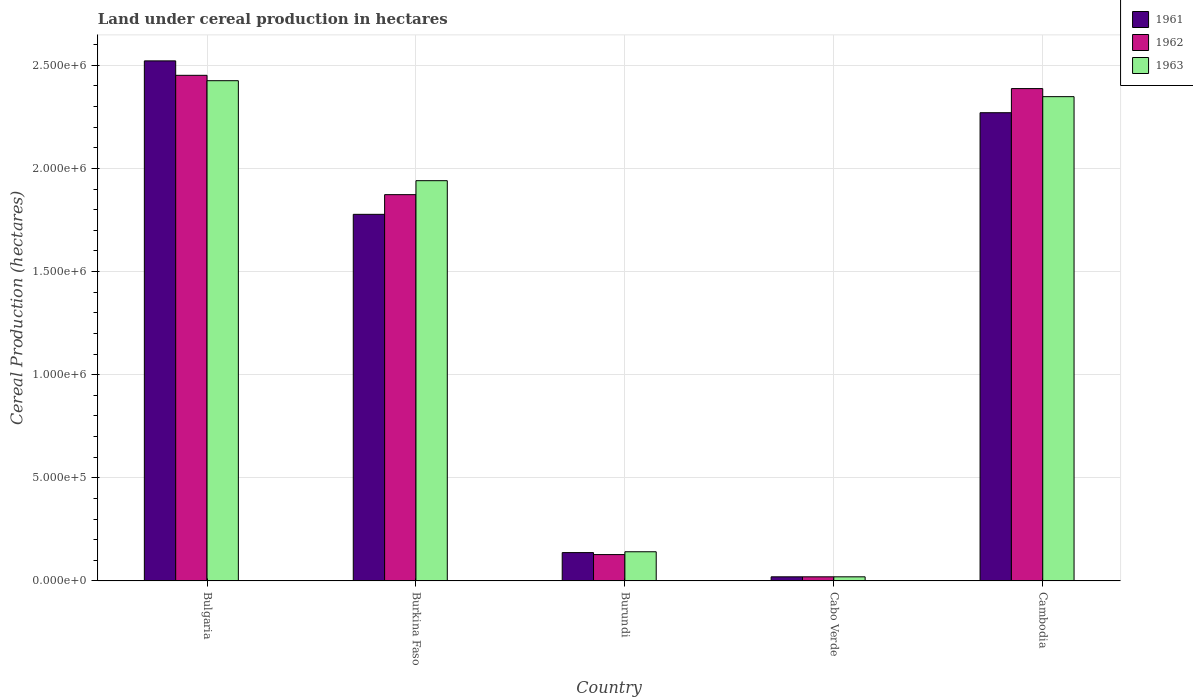How many different coloured bars are there?
Ensure brevity in your answer.  3. How many groups of bars are there?
Provide a short and direct response. 5. Are the number of bars per tick equal to the number of legend labels?
Make the answer very short. Yes. How many bars are there on the 4th tick from the left?
Ensure brevity in your answer.  3. What is the label of the 3rd group of bars from the left?
Provide a short and direct response. Burundi. In how many cases, is the number of bars for a given country not equal to the number of legend labels?
Ensure brevity in your answer.  0. Across all countries, what is the maximum land under cereal production in 1963?
Keep it short and to the point. 2.43e+06. Across all countries, what is the minimum land under cereal production in 1962?
Provide a succinct answer. 2.00e+04. In which country was the land under cereal production in 1961 maximum?
Ensure brevity in your answer.  Bulgaria. In which country was the land under cereal production in 1961 minimum?
Ensure brevity in your answer.  Cabo Verde. What is the total land under cereal production in 1963 in the graph?
Your answer should be compact. 6.88e+06. What is the difference between the land under cereal production in 1963 in Burkina Faso and that in Cambodia?
Make the answer very short. -4.07e+05. What is the difference between the land under cereal production in 1961 in Cabo Verde and the land under cereal production in 1963 in Burkina Faso?
Make the answer very short. -1.92e+06. What is the average land under cereal production in 1962 per country?
Your response must be concise. 1.37e+06. What is the difference between the land under cereal production of/in 1961 and land under cereal production of/in 1962 in Burundi?
Your answer should be compact. 9597. What is the ratio of the land under cereal production in 1963 in Bulgaria to that in Cabo Verde?
Offer a very short reply. 121.26. Is the land under cereal production in 1963 in Burkina Faso less than that in Cambodia?
Offer a terse response. Yes. What is the difference between the highest and the second highest land under cereal production in 1963?
Your answer should be very brief. -7.73e+04. What is the difference between the highest and the lowest land under cereal production in 1961?
Offer a terse response. 2.50e+06. What does the 2nd bar from the left in Bulgaria represents?
Your response must be concise. 1962. What does the 2nd bar from the right in Bulgaria represents?
Your answer should be compact. 1962. Are all the bars in the graph horizontal?
Ensure brevity in your answer.  No. Are the values on the major ticks of Y-axis written in scientific E-notation?
Provide a short and direct response. Yes. What is the title of the graph?
Your answer should be very brief. Land under cereal production in hectares. Does "2005" appear as one of the legend labels in the graph?
Give a very brief answer. No. What is the label or title of the X-axis?
Offer a terse response. Country. What is the label or title of the Y-axis?
Keep it short and to the point. Cereal Production (hectares). What is the Cereal Production (hectares) in 1961 in Bulgaria?
Make the answer very short. 2.52e+06. What is the Cereal Production (hectares) of 1962 in Bulgaria?
Offer a very short reply. 2.45e+06. What is the Cereal Production (hectares) of 1963 in Bulgaria?
Your answer should be very brief. 2.43e+06. What is the Cereal Production (hectares) in 1961 in Burkina Faso?
Offer a very short reply. 1.78e+06. What is the Cereal Production (hectares) of 1962 in Burkina Faso?
Offer a very short reply. 1.87e+06. What is the Cereal Production (hectares) in 1963 in Burkina Faso?
Give a very brief answer. 1.94e+06. What is the Cereal Production (hectares) in 1961 in Burundi?
Provide a short and direct response. 1.37e+05. What is the Cereal Production (hectares) of 1962 in Burundi?
Your answer should be very brief. 1.28e+05. What is the Cereal Production (hectares) of 1963 in Burundi?
Your answer should be very brief. 1.41e+05. What is the Cereal Production (hectares) of 1961 in Cambodia?
Ensure brevity in your answer.  2.27e+06. What is the Cereal Production (hectares) in 1962 in Cambodia?
Offer a very short reply. 2.39e+06. What is the Cereal Production (hectares) in 1963 in Cambodia?
Offer a terse response. 2.35e+06. Across all countries, what is the maximum Cereal Production (hectares) in 1961?
Make the answer very short. 2.52e+06. Across all countries, what is the maximum Cereal Production (hectares) in 1962?
Give a very brief answer. 2.45e+06. Across all countries, what is the maximum Cereal Production (hectares) in 1963?
Ensure brevity in your answer.  2.43e+06. Across all countries, what is the minimum Cereal Production (hectares) in 1962?
Your response must be concise. 2.00e+04. Across all countries, what is the minimum Cereal Production (hectares) of 1963?
Provide a short and direct response. 2.00e+04. What is the total Cereal Production (hectares) in 1961 in the graph?
Keep it short and to the point. 6.73e+06. What is the total Cereal Production (hectares) in 1962 in the graph?
Offer a very short reply. 6.86e+06. What is the total Cereal Production (hectares) in 1963 in the graph?
Your response must be concise. 6.88e+06. What is the difference between the Cereal Production (hectares) of 1961 in Bulgaria and that in Burkina Faso?
Your answer should be compact. 7.44e+05. What is the difference between the Cereal Production (hectares) in 1962 in Bulgaria and that in Burkina Faso?
Provide a short and direct response. 5.79e+05. What is the difference between the Cereal Production (hectares) of 1963 in Bulgaria and that in Burkina Faso?
Offer a very short reply. 4.85e+05. What is the difference between the Cereal Production (hectares) of 1961 in Bulgaria and that in Burundi?
Provide a succinct answer. 2.38e+06. What is the difference between the Cereal Production (hectares) in 1962 in Bulgaria and that in Burundi?
Provide a succinct answer. 2.32e+06. What is the difference between the Cereal Production (hectares) in 1963 in Bulgaria and that in Burundi?
Your answer should be very brief. 2.28e+06. What is the difference between the Cereal Production (hectares) in 1961 in Bulgaria and that in Cabo Verde?
Your answer should be compact. 2.50e+06. What is the difference between the Cereal Production (hectares) in 1962 in Bulgaria and that in Cabo Verde?
Give a very brief answer. 2.43e+06. What is the difference between the Cereal Production (hectares) in 1963 in Bulgaria and that in Cabo Verde?
Provide a succinct answer. 2.41e+06. What is the difference between the Cereal Production (hectares) in 1961 in Bulgaria and that in Cambodia?
Give a very brief answer. 2.51e+05. What is the difference between the Cereal Production (hectares) in 1962 in Bulgaria and that in Cambodia?
Ensure brevity in your answer.  6.43e+04. What is the difference between the Cereal Production (hectares) in 1963 in Bulgaria and that in Cambodia?
Your response must be concise. 7.73e+04. What is the difference between the Cereal Production (hectares) in 1961 in Burkina Faso and that in Burundi?
Ensure brevity in your answer.  1.64e+06. What is the difference between the Cereal Production (hectares) in 1962 in Burkina Faso and that in Burundi?
Your response must be concise. 1.75e+06. What is the difference between the Cereal Production (hectares) of 1963 in Burkina Faso and that in Burundi?
Make the answer very short. 1.80e+06. What is the difference between the Cereal Production (hectares) of 1961 in Burkina Faso and that in Cabo Verde?
Your answer should be compact. 1.76e+06. What is the difference between the Cereal Production (hectares) of 1962 in Burkina Faso and that in Cabo Verde?
Make the answer very short. 1.85e+06. What is the difference between the Cereal Production (hectares) of 1963 in Burkina Faso and that in Cabo Verde?
Give a very brief answer. 1.92e+06. What is the difference between the Cereal Production (hectares) of 1961 in Burkina Faso and that in Cambodia?
Provide a short and direct response. -4.93e+05. What is the difference between the Cereal Production (hectares) of 1962 in Burkina Faso and that in Cambodia?
Make the answer very short. -5.14e+05. What is the difference between the Cereal Production (hectares) in 1963 in Burkina Faso and that in Cambodia?
Provide a succinct answer. -4.07e+05. What is the difference between the Cereal Production (hectares) of 1961 in Burundi and that in Cabo Verde?
Keep it short and to the point. 1.17e+05. What is the difference between the Cereal Production (hectares) in 1962 in Burundi and that in Cabo Verde?
Give a very brief answer. 1.08e+05. What is the difference between the Cereal Production (hectares) in 1963 in Burundi and that in Cabo Verde?
Your response must be concise. 1.21e+05. What is the difference between the Cereal Production (hectares) of 1961 in Burundi and that in Cambodia?
Your response must be concise. -2.13e+06. What is the difference between the Cereal Production (hectares) in 1962 in Burundi and that in Cambodia?
Offer a very short reply. -2.26e+06. What is the difference between the Cereal Production (hectares) of 1963 in Burundi and that in Cambodia?
Ensure brevity in your answer.  -2.21e+06. What is the difference between the Cereal Production (hectares) in 1961 in Cabo Verde and that in Cambodia?
Give a very brief answer. -2.25e+06. What is the difference between the Cereal Production (hectares) of 1962 in Cabo Verde and that in Cambodia?
Offer a terse response. -2.37e+06. What is the difference between the Cereal Production (hectares) of 1963 in Cabo Verde and that in Cambodia?
Provide a succinct answer. -2.33e+06. What is the difference between the Cereal Production (hectares) of 1961 in Bulgaria and the Cereal Production (hectares) of 1962 in Burkina Faso?
Your answer should be compact. 6.49e+05. What is the difference between the Cereal Production (hectares) in 1961 in Bulgaria and the Cereal Production (hectares) in 1963 in Burkina Faso?
Ensure brevity in your answer.  5.81e+05. What is the difference between the Cereal Production (hectares) of 1962 in Bulgaria and the Cereal Production (hectares) of 1963 in Burkina Faso?
Offer a terse response. 5.11e+05. What is the difference between the Cereal Production (hectares) of 1961 in Bulgaria and the Cereal Production (hectares) of 1962 in Burundi?
Provide a succinct answer. 2.39e+06. What is the difference between the Cereal Production (hectares) of 1961 in Bulgaria and the Cereal Production (hectares) of 1963 in Burundi?
Provide a succinct answer. 2.38e+06. What is the difference between the Cereal Production (hectares) in 1962 in Bulgaria and the Cereal Production (hectares) in 1963 in Burundi?
Provide a succinct answer. 2.31e+06. What is the difference between the Cereal Production (hectares) in 1961 in Bulgaria and the Cereal Production (hectares) in 1962 in Cabo Verde?
Offer a very short reply. 2.50e+06. What is the difference between the Cereal Production (hectares) in 1961 in Bulgaria and the Cereal Production (hectares) in 1963 in Cabo Verde?
Give a very brief answer. 2.50e+06. What is the difference between the Cereal Production (hectares) in 1962 in Bulgaria and the Cereal Production (hectares) in 1963 in Cabo Verde?
Give a very brief answer. 2.43e+06. What is the difference between the Cereal Production (hectares) in 1961 in Bulgaria and the Cereal Production (hectares) in 1962 in Cambodia?
Offer a very short reply. 1.34e+05. What is the difference between the Cereal Production (hectares) in 1961 in Bulgaria and the Cereal Production (hectares) in 1963 in Cambodia?
Your answer should be compact. 1.73e+05. What is the difference between the Cereal Production (hectares) of 1962 in Bulgaria and the Cereal Production (hectares) of 1963 in Cambodia?
Your answer should be very brief. 1.03e+05. What is the difference between the Cereal Production (hectares) in 1961 in Burkina Faso and the Cereal Production (hectares) in 1962 in Burundi?
Your response must be concise. 1.65e+06. What is the difference between the Cereal Production (hectares) of 1961 in Burkina Faso and the Cereal Production (hectares) of 1963 in Burundi?
Keep it short and to the point. 1.64e+06. What is the difference between the Cereal Production (hectares) of 1962 in Burkina Faso and the Cereal Production (hectares) of 1963 in Burundi?
Your response must be concise. 1.73e+06. What is the difference between the Cereal Production (hectares) in 1961 in Burkina Faso and the Cereal Production (hectares) in 1962 in Cabo Verde?
Make the answer very short. 1.76e+06. What is the difference between the Cereal Production (hectares) of 1961 in Burkina Faso and the Cereal Production (hectares) of 1963 in Cabo Verde?
Keep it short and to the point. 1.76e+06. What is the difference between the Cereal Production (hectares) in 1962 in Burkina Faso and the Cereal Production (hectares) in 1963 in Cabo Verde?
Ensure brevity in your answer.  1.85e+06. What is the difference between the Cereal Production (hectares) in 1961 in Burkina Faso and the Cereal Production (hectares) in 1962 in Cambodia?
Provide a short and direct response. -6.10e+05. What is the difference between the Cereal Production (hectares) of 1961 in Burkina Faso and the Cereal Production (hectares) of 1963 in Cambodia?
Your response must be concise. -5.71e+05. What is the difference between the Cereal Production (hectares) of 1962 in Burkina Faso and the Cereal Production (hectares) of 1963 in Cambodia?
Your answer should be compact. -4.75e+05. What is the difference between the Cereal Production (hectares) in 1961 in Burundi and the Cereal Production (hectares) in 1962 in Cabo Verde?
Your answer should be compact. 1.17e+05. What is the difference between the Cereal Production (hectares) in 1961 in Burundi and the Cereal Production (hectares) in 1963 in Cabo Verde?
Offer a very short reply. 1.17e+05. What is the difference between the Cereal Production (hectares) of 1962 in Burundi and the Cereal Production (hectares) of 1963 in Cabo Verde?
Keep it short and to the point. 1.08e+05. What is the difference between the Cereal Production (hectares) in 1961 in Burundi and the Cereal Production (hectares) in 1962 in Cambodia?
Your answer should be compact. -2.25e+06. What is the difference between the Cereal Production (hectares) in 1961 in Burundi and the Cereal Production (hectares) in 1963 in Cambodia?
Offer a terse response. -2.21e+06. What is the difference between the Cereal Production (hectares) in 1962 in Burundi and the Cereal Production (hectares) in 1963 in Cambodia?
Give a very brief answer. -2.22e+06. What is the difference between the Cereal Production (hectares) of 1961 in Cabo Verde and the Cereal Production (hectares) of 1962 in Cambodia?
Offer a very short reply. -2.37e+06. What is the difference between the Cereal Production (hectares) of 1961 in Cabo Verde and the Cereal Production (hectares) of 1963 in Cambodia?
Provide a short and direct response. -2.33e+06. What is the difference between the Cereal Production (hectares) of 1962 in Cabo Verde and the Cereal Production (hectares) of 1963 in Cambodia?
Ensure brevity in your answer.  -2.33e+06. What is the average Cereal Production (hectares) of 1961 per country?
Provide a succinct answer. 1.35e+06. What is the average Cereal Production (hectares) in 1962 per country?
Your answer should be very brief. 1.37e+06. What is the average Cereal Production (hectares) in 1963 per country?
Keep it short and to the point. 1.38e+06. What is the difference between the Cereal Production (hectares) of 1961 and Cereal Production (hectares) of 1962 in Bulgaria?
Offer a terse response. 7.00e+04. What is the difference between the Cereal Production (hectares) of 1961 and Cereal Production (hectares) of 1963 in Bulgaria?
Give a very brief answer. 9.61e+04. What is the difference between the Cereal Production (hectares) in 1962 and Cereal Production (hectares) in 1963 in Bulgaria?
Your answer should be very brief. 2.61e+04. What is the difference between the Cereal Production (hectares) of 1961 and Cereal Production (hectares) of 1962 in Burkina Faso?
Provide a succinct answer. -9.54e+04. What is the difference between the Cereal Production (hectares) in 1961 and Cereal Production (hectares) in 1963 in Burkina Faso?
Ensure brevity in your answer.  -1.63e+05. What is the difference between the Cereal Production (hectares) of 1962 and Cereal Production (hectares) of 1963 in Burkina Faso?
Offer a terse response. -6.77e+04. What is the difference between the Cereal Production (hectares) in 1961 and Cereal Production (hectares) in 1962 in Burundi?
Offer a very short reply. 9597. What is the difference between the Cereal Production (hectares) of 1961 and Cereal Production (hectares) of 1963 in Burundi?
Offer a terse response. -4063. What is the difference between the Cereal Production (hectares) in 1962 and Cereal Production (hectares) in 1963 in Burundi?
Offer a terse response. -1.37e+04. What is the difference between the Cereal Production (hectares) of 1961 and Cereal Production (hectares) of 1962 in Cabo Verde?
Give a very brief answer. 0. What is the difference between the Cereal Production (hectares) in 1961 and Cereal Production (hectares) in 1963 in Cabo Verde?
Your response must be concise. 0. What is the difference between the Cereal Production (hectares) of 1962 and Cereal Production (hectares) of 1963 in Cabo Verde?
Provide a succinct answer. 0. What is the difference between the Cereal Production (hectares) in 1961 and Cereal Production (hectares) in 1962 in Cambodia?
Make the answer very short. -1.17e+05. What is the difference between the Cereal Production (hectares) in 1961 and Cereal Production (hectares) in 1963 in Cambodia?
Your answer should be very brief. -7.79e+04. What is the difference between the Cereal Production (hectares) in 1962 and Cereal Production (hectares) in 1963 in Cambodia?
Provide a succinct answer. 3.91e+04. What is the ratio of the Cereal Production (hectares) in 1961 in Bulgaria to that in Burkina Faso?
Offer a very short reply. 1.42. What is the ratio of the Cereal Production (hectares) in 1962 in Bulgaria to that in Burkina Faso?
Provide a succinct answer. 1.31. What is the ratio of the Cereal Production (hectares) of 1963 in Bulgaria to that in Burkina Faso?
Your response must be concise. 1.25. What is the ratio of the Cereal Production (hectares) of 1961 in Bulgaria to that in Burundi?
Your answer should be very brief. 18.35. What is the ratio of the Cereal Production (hectares) in 1962 in Bulgaria to that in Burundi?
Offer a very short reply. 19.18. What is the ratio of the Cereal Production (hectares) of 1963 in Bulgaria to that in Burundi?
Ensure brevity in your answer.  17.14. What is the ratio of the Cereal Production (hectares) of 1961 in Bulgaria to that in Cabo Verde?
Give a very brief answer. 126.07. What is the ratio of the Cereal Production (hectares) of 1962 in Bulgaria to that in Cabo Verde?
Give a very brief answer. 122.57. What is the ratio of the Cereal Production (hectares) of 1963 in Bulgaria to that in Cabo Verde?
Make the answer very short. 121.26. What is the ratio of the Cereal Production (hectares) in 1961 in Bulgaria to that in Cambodia?
Give a very brief answer. 1.11. What is the ratio of the Cereal Production (hectares) of 1962 in Bulgaria to that in Cambodia?
Keep it short and to the point. 1.03. What is the ratio of the Cereal Production (hectares) of 1963 in Bulgaria to that in Cambodia?
Provide a short and direct response. 1.03. What is the ratio of the Cereal Production (hectares) of 1961 in Burkina Faso to that in Burundi?
Your response must be concise. 12.94. What is the ratio of the Cereal Production (hectares) of 1962 in Burkina Faso to that in Burundi?
Provide a short and direct response. 14.65. What is the ratio of the Cereal Production (hectares) in 1963 in Burkina Faso to that in Burundi?
Make the answer very short. 13.72. What is the ratio of the Cereal Production (hectares) in 1961 in Burkina Faso to that in Cabo Verde?
Your response must be concise. 88.87. What is the ratio of the Cereal Production (hectares) in 1962 in Burkina Faso to that in Cabo Verde?
Your answer should be very brief. 93.64. What is the ratio of the Cereal Production (hectares) in 1963 in Burkina Faso to that in Cabo Verde?
Offer a terse response. 97.03. What is the ratio of the Cereal Production (hectares) in 1961 in Burkina Faso to that in Cambodia?
Offer a very short reply. 0.78. What is the ratio of the Cereal Production (hectares) in 1962 in Burkina Faso to that in Cambodia?
Ensure brevity in your answer.  0.78. What is the ratio of the Cereal Production (hectares) of 1963 in Burkina Faso to that in Cambodia?
Provide a short and direct response. 0.83. What is the ratio of the Cereal Production (hectares) of 1961 in Burundi to that in Cabo Verde?
Your answer should be very brief. 6.87. What is the ratio of the Cereal Production (hectares) of 1962 in Burundi to that in Cabo Verde?
Your answer should be very brief. 6.39. What is the ratio of the Cereal Production (hectares) in 1963 in Burundi to that in Cabo Verde?
Make the answer very short. 7.07. What is the ratio of the Cereal Production (hectares) of 1961 in Burundi to that in Cambodia?
Make the answer very short. 0.06. What is the ratio of the Cereal Production (hectares) in 1962 in Burundi to that in Cambodia?
Offer a terse response. 0.05. What is the ratio of the Cereal Production (hectares) in 1963 in Burundi to that in Cambodia?
Your answer should be compact. 0.06. What is the ratio of the Cereal Production (hectares) in 1961 in Cabo Verde to that in Cambodia?
Keep it short and to the point. 0.01. What is the ratio of the Cereal Production (hectares) in 1962 in Cabo Verde to that in Cambodia?
Offer a terse response. 0.01. What is the ratio of the Cereal Production (hectares) in 1963 in Cabo Verde to that in Cambodia?
Provide a short and direct response. 0.01. What is the difference between the highest and the second highest Cereal Production (hectares) in 1961?
Your response must be concise. 2.51e+05. What is the difference between the highest and the second highest Cereal Production (hectares) in 1962?
Provide a short and direct response. 6.43e+04. What is the difference between the highest and the second highest Cereal Production (hectares) in 1963?
Offer a very short reply. 7.73e+04. What is the difference between the highest and the lowest Cereal Production (hectares) of 1961?
Keep it short and to the point. 2.50e+06. What is the difference between the highest and the lowest Cereal Production (hectares) of 1962?
Provide a succinct answer. 2.43e+06. What is the difference between the highest and the lowest Cereal Production (hectares) in 1963?
Offer a very short reply. 2.41e+06. 